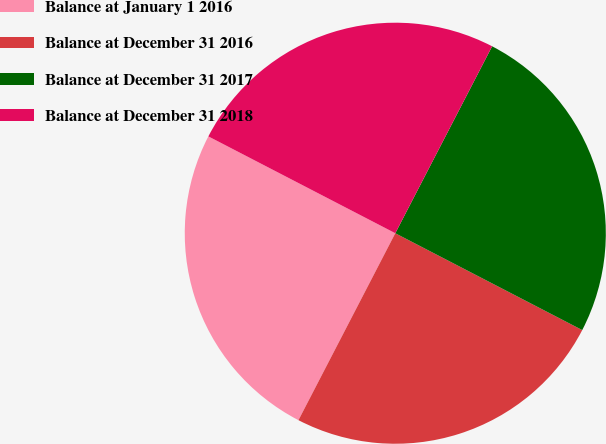<chart> <loc_0><loc_0><loc_500><loc_500><pie_chart><fcel>Balance at January 1 2016<fcel>Balance at December 31 2016<fcel>Balance at December 31 2017<fcel>Balance at December 31 2018<nl><fcel>25.0%<fcel>25.0%<fcel>25.0%<fcel>25.0%<nl></chart> 